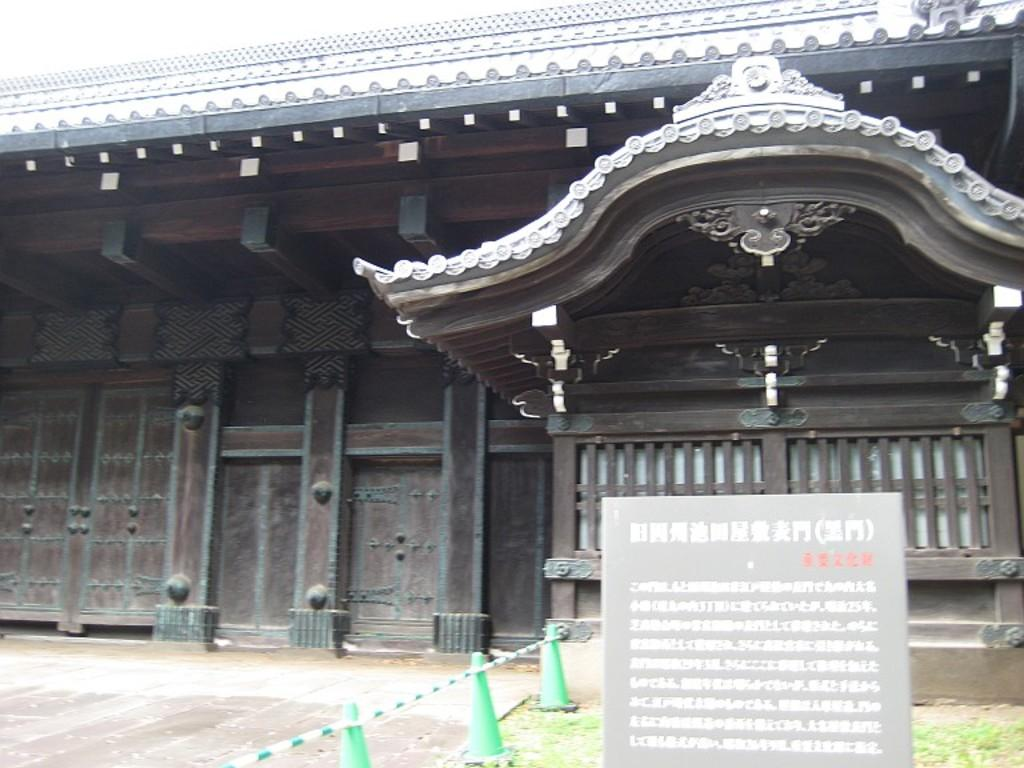What type of structure is visible in the image? There is a building in the image. What is located at the bottom of the image? There is a banner and grass at the bottom of the image. What type of barrier is present in the image? There is fencing in the image. How many boots can be seen in the image? There are no boots present in the image. What type of birds are swimming in the pond in the image? There is no pond or ducks present in the image. 